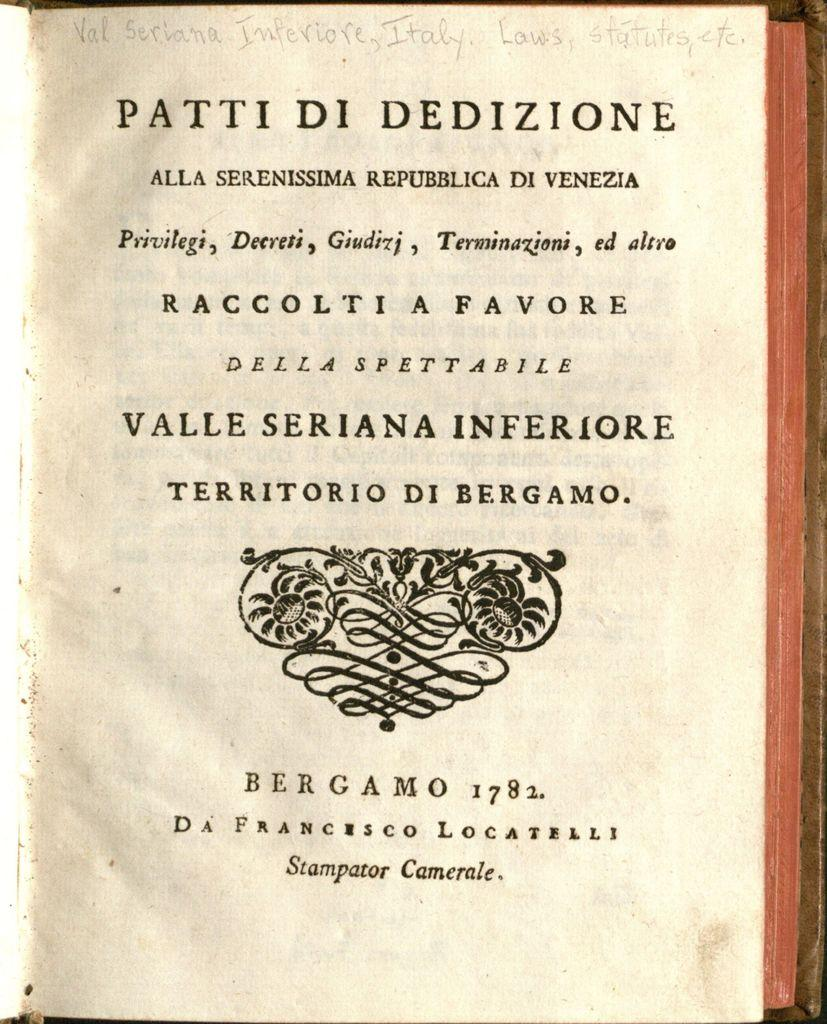<image>
Describe the image concisely. A Patti Di Dedizione book with the year 1782 written on the page. 